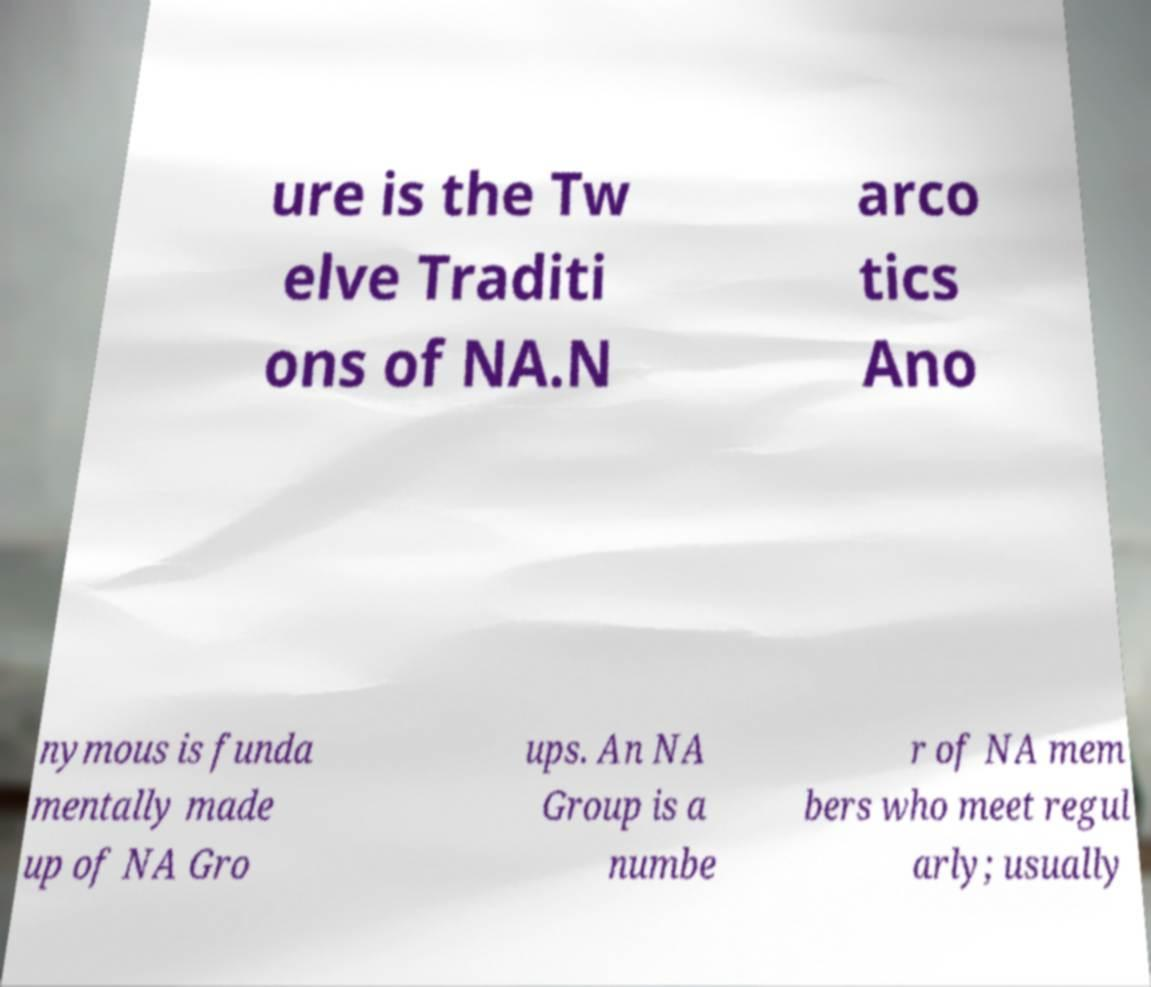I need the written content from this picture converted into text. Can you do that? ure is the Tw elve Traditi ons of NA.N arco tics Ano nymous is funda mentally made up of NA Gro ups. An NA Group is a numbe r of NA mem bers who meet regul arly; usually 